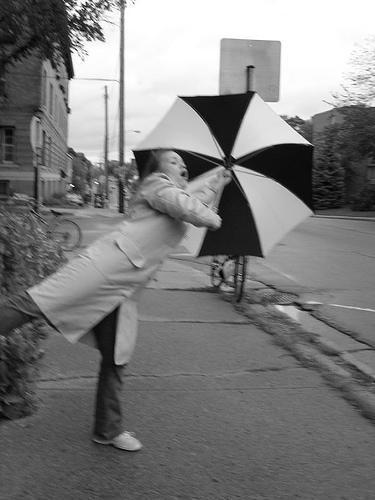How many umbrellas in the photo?
Give a very brief answer. 1. 